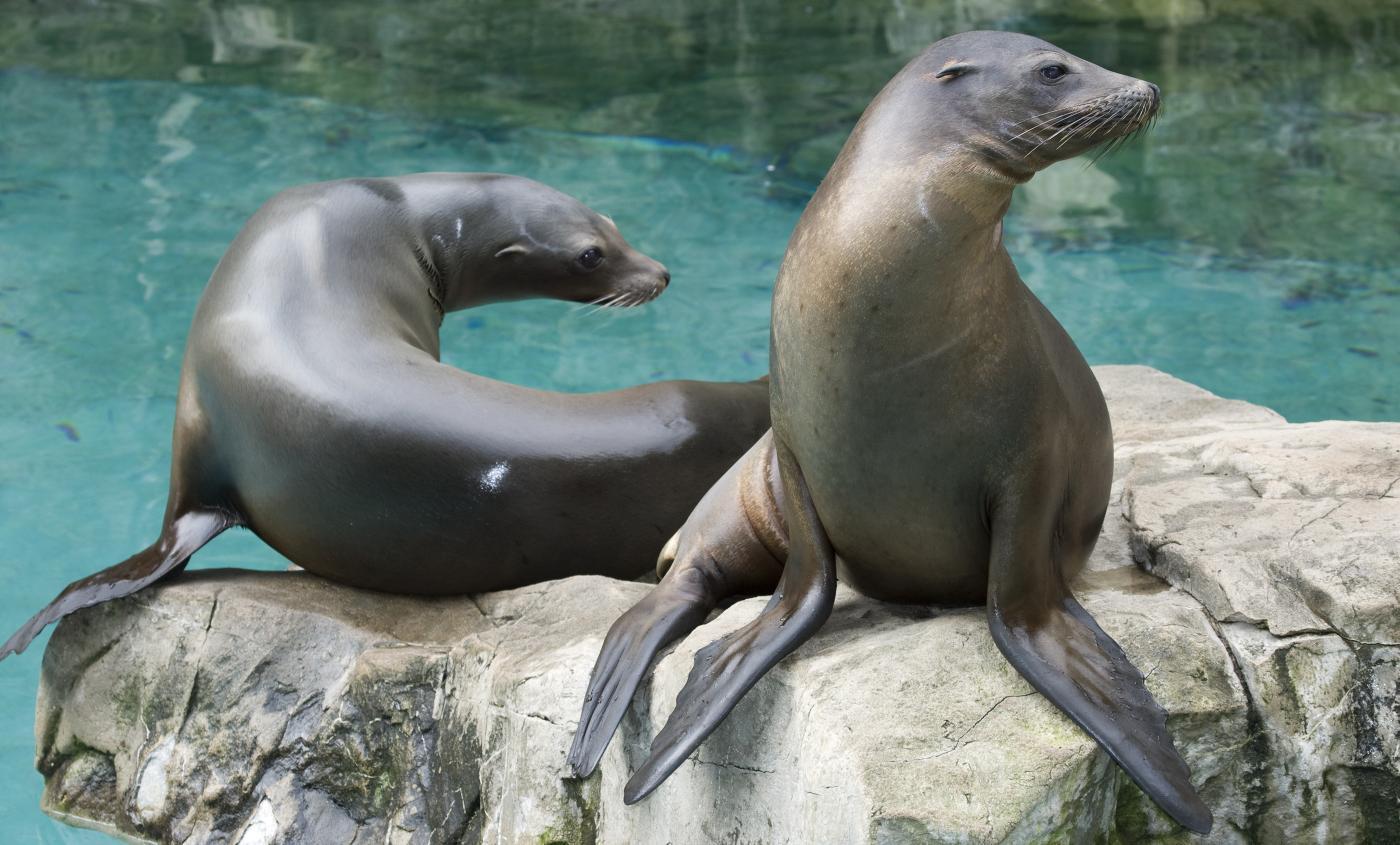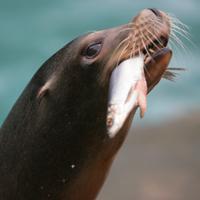The first image is the image on the left, the second image is the image on the right. For the images displayed, is the sentence "The seal in the right image has a fish in it's mouth." factually correct? Answer yes or no. Yes. The first image is the image on the left, the second image is the image on the right. For the images displayed, is the sentence "There is a seal with a fish hanging from the left side of their mouth" factually correct? Answer yes or no. Yes. 